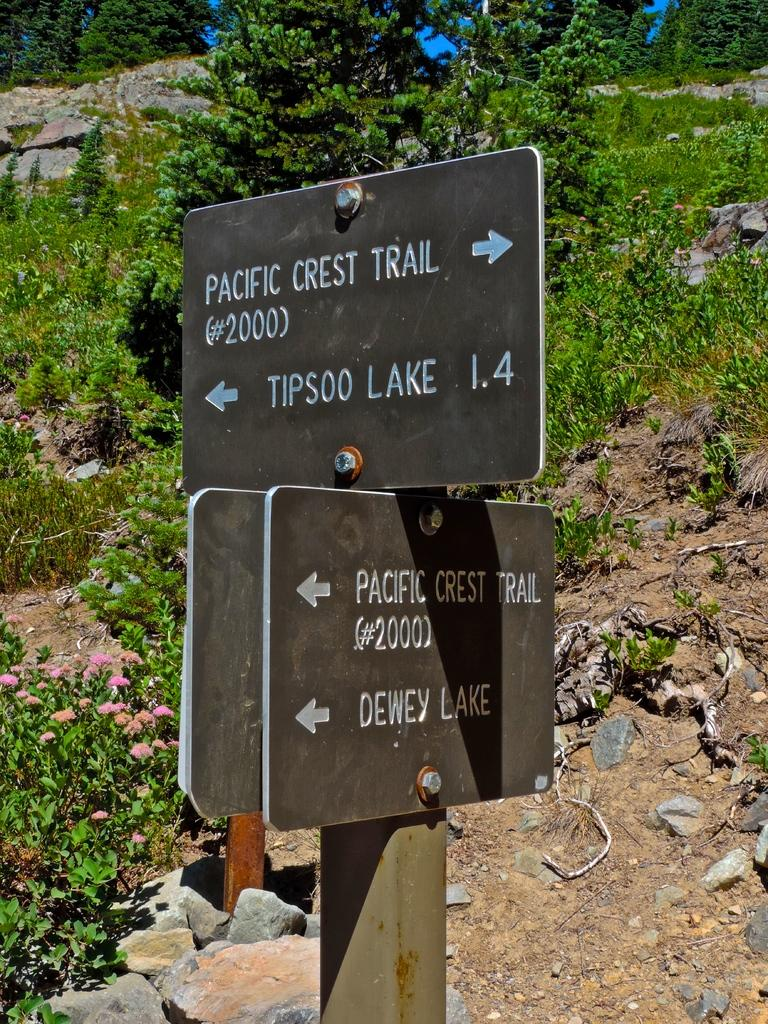What is located in the foreground of the image? There is a sign board in the foreground of the image. What can be seen in the background of the image? There are plants, flowers, and rocks in the background of the image. How many tramps are visible in the image? There are no tramps present in the image. What type of wrist accessory is being worn by the plants in the image? The plants in the image do not have wrists or any accessories. 